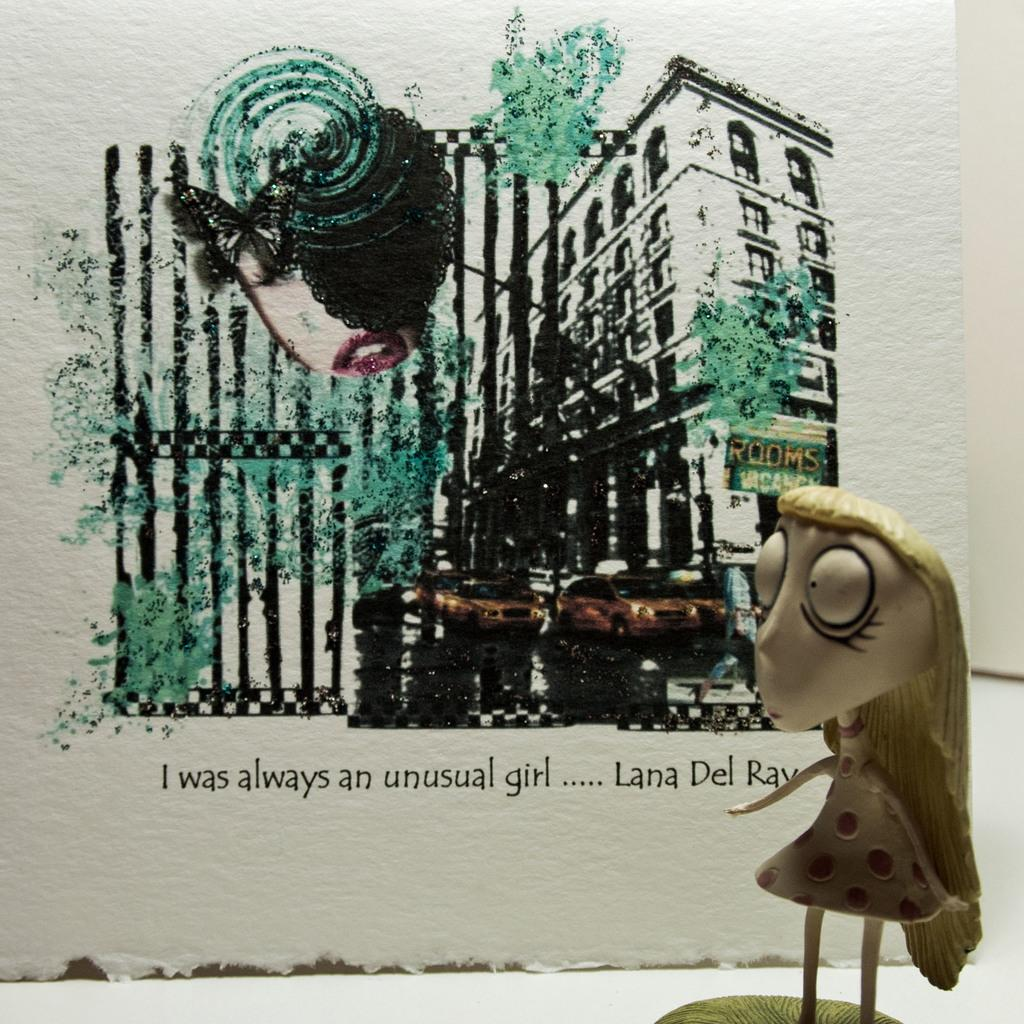What is the main object in the front of the image? There is a toy in the front of the image. What can be seen in the background of the image? There is a board in the background of the image. What is depicted on the board? There is a picture of a building and cars on the board. Is there any text on the board? Yes, there is some text on the board. What type of weather can be seen in the image? There is no weather depicted in the image; it is a still scene with a toy, board, and text. Can you see an ant crawling on the board in the image? There is no ant present in the image. 